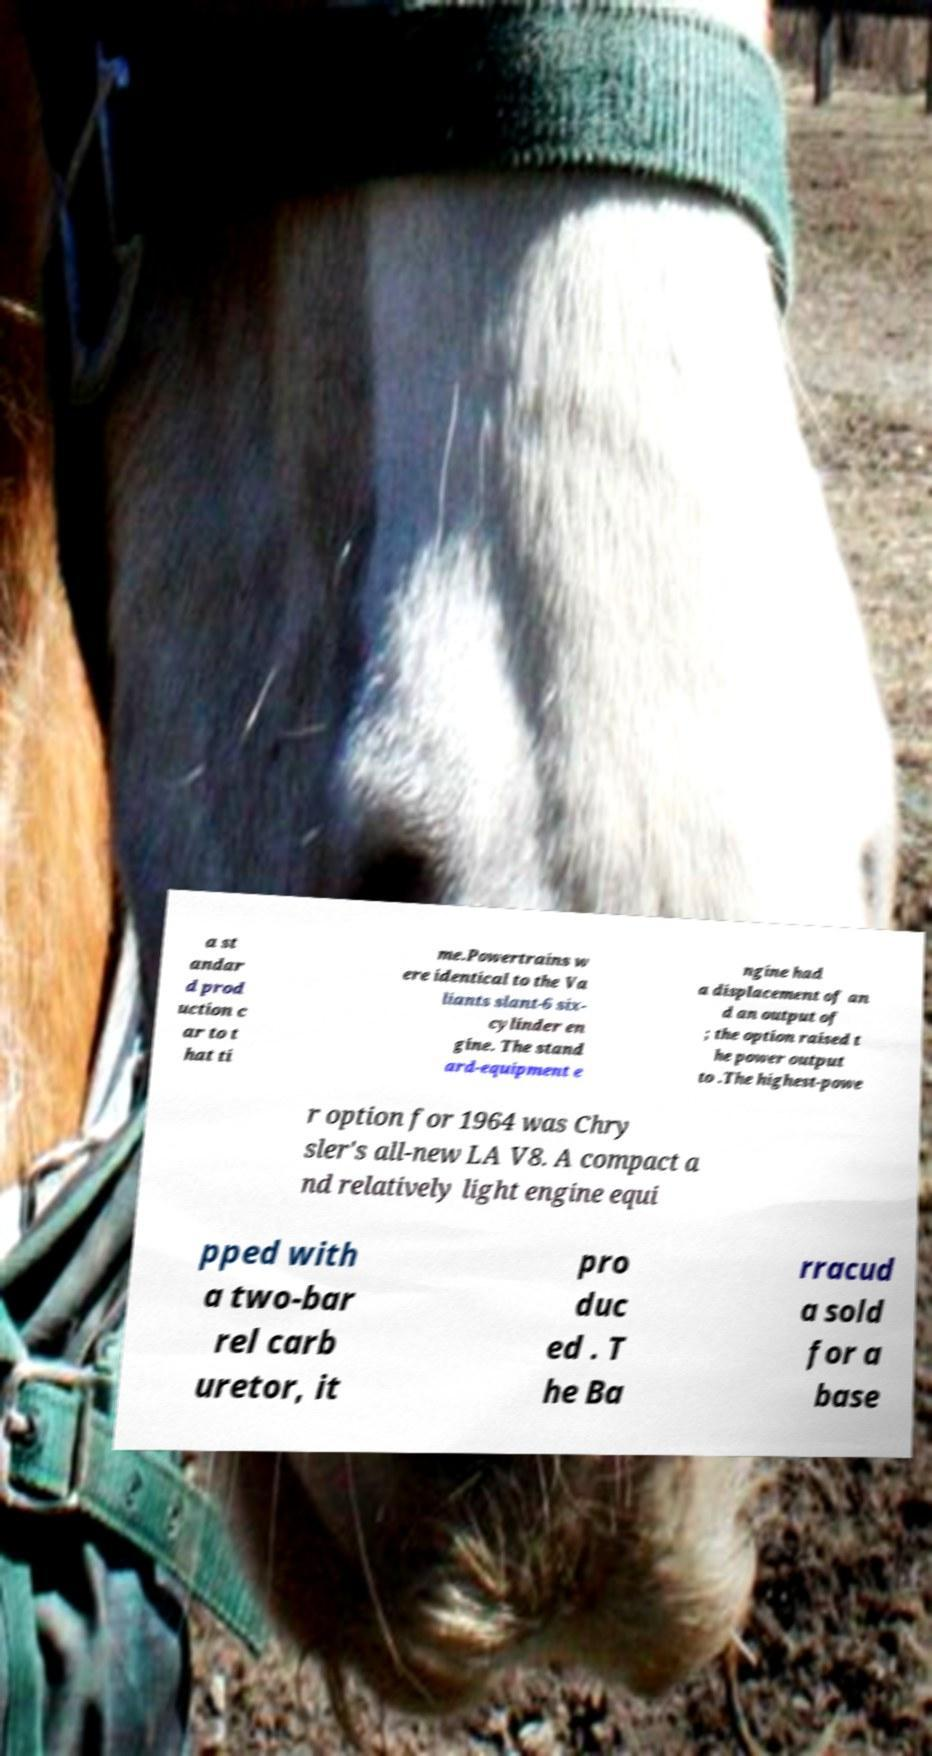Please identify and transcribe the text found in this image. a st andar d prod uction c ar to t hat ti me.Powertrains w ere identical to the Va liants slant-6 six- cylinder en gine. The stand ard-equipment e ngine had a displacement of an d an output of ; the option raised t he power output to .The highest-powe r option for 1964 was Chry sler's all-new LA V8. A compact a nd relatively light engine equi pped with a two-bar rel carb uretor, it pro duc ed . T he Ba rracud a sold for a base 